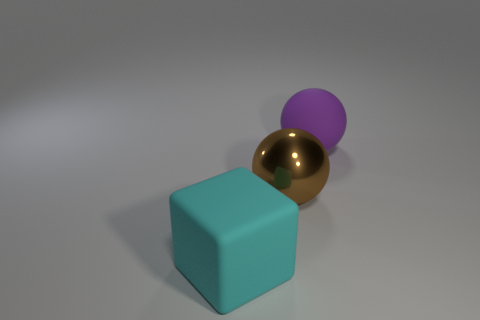Add 2 small purple metal cylinders. How many objects exist? 5 Subtract all balls. How many objects are left? 1 Add 3 big shiny things. How many big shiny things are left? 4 Add 2 spheres. How many spheres exist? 4 Subtract 1 brown balls. How many objects are left? 2 Subtract all shiny things. Subtract all big purple rubber spheres. How many objects are left? 1 